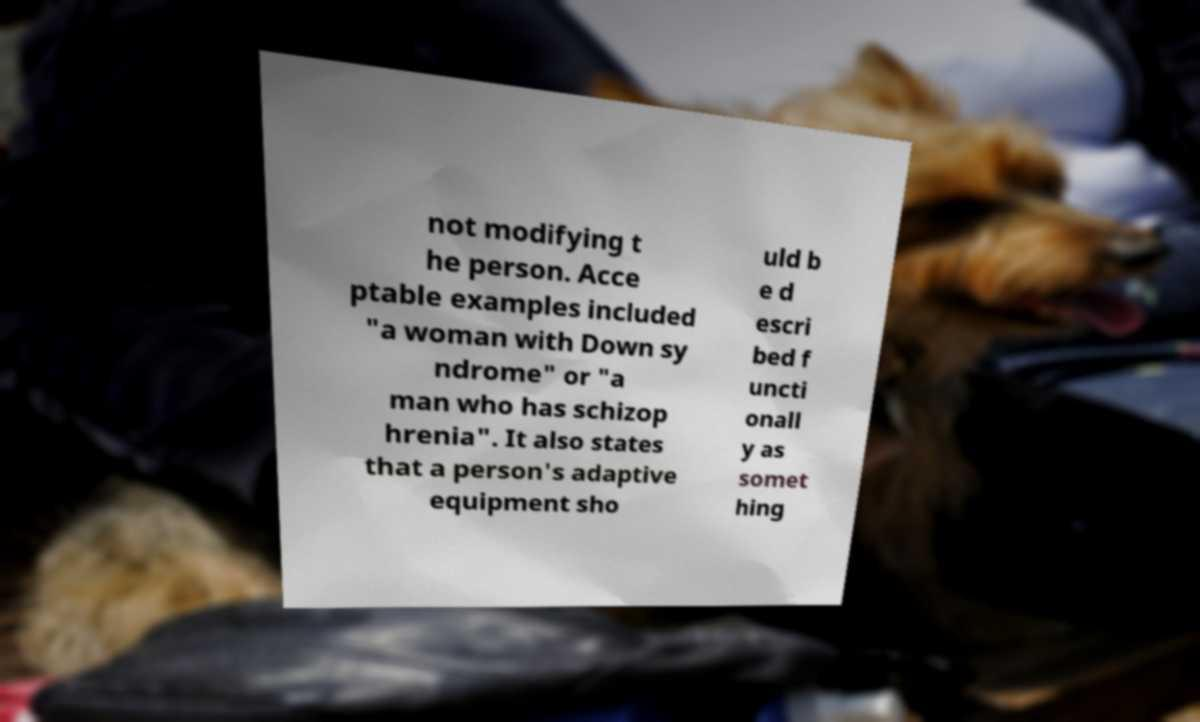For documentation purposes, I need the text within this image transcribed. Could you provide that? not modifying t he person. Acce ptable examples included "a woman with Down sy ndrome" or "a man who has schizop hrenia". It also states that a person's adaptive equipment sho uld b e d escri bed f uncti onall y as somet hing 